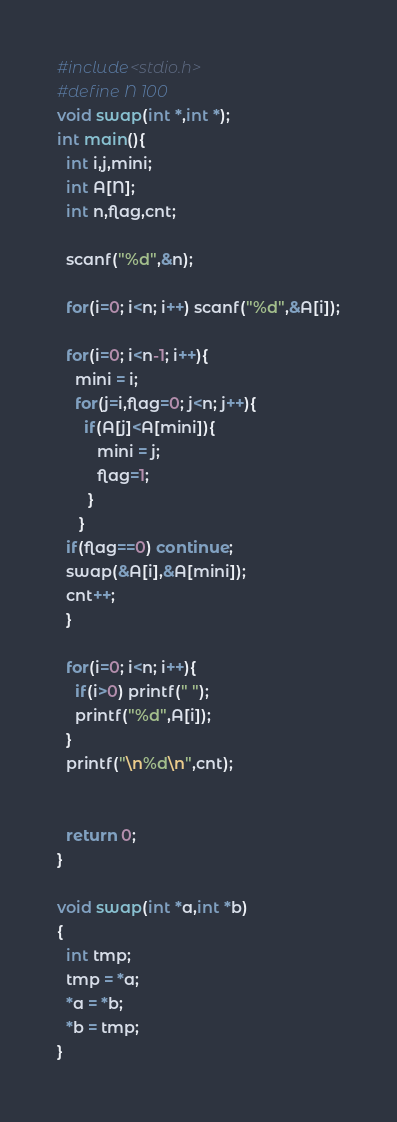Convert code to text. <code><loc_0><loc_0><loc_500><loc_500><_C_>#include<stdio.h>
#define N 100
void swap(int *,int *);
int main(){
  int i,j,mini;
  int A[N];
  int n,flag,cnt;

  scanf("%d",&n);

  for(i=0; i<n; i++) scanf("%d",&A[i]);

  for(i=0; i<n-1; i++){
    mini = i;
    for(j=i,flag=0; j<n; j++){
      if(A[j]<A[mini]){
         mini = j;
         flag=1;
       }
     }
  if(flag==0) continue;
  swap(&A[i],&A[mini]);
  cnt++;
  }

  for(i=0; i<n; i++){
    if(i>0) printf(" ");
    printf("%d",A[i]);
  }
  printf("\n%d\n",cnt);


  return 0;
}

void swap(int *a,int *b)
{
  int tmp;
  tmp = *a;
  *a = *b;
  *b = tmp;
}</code> 